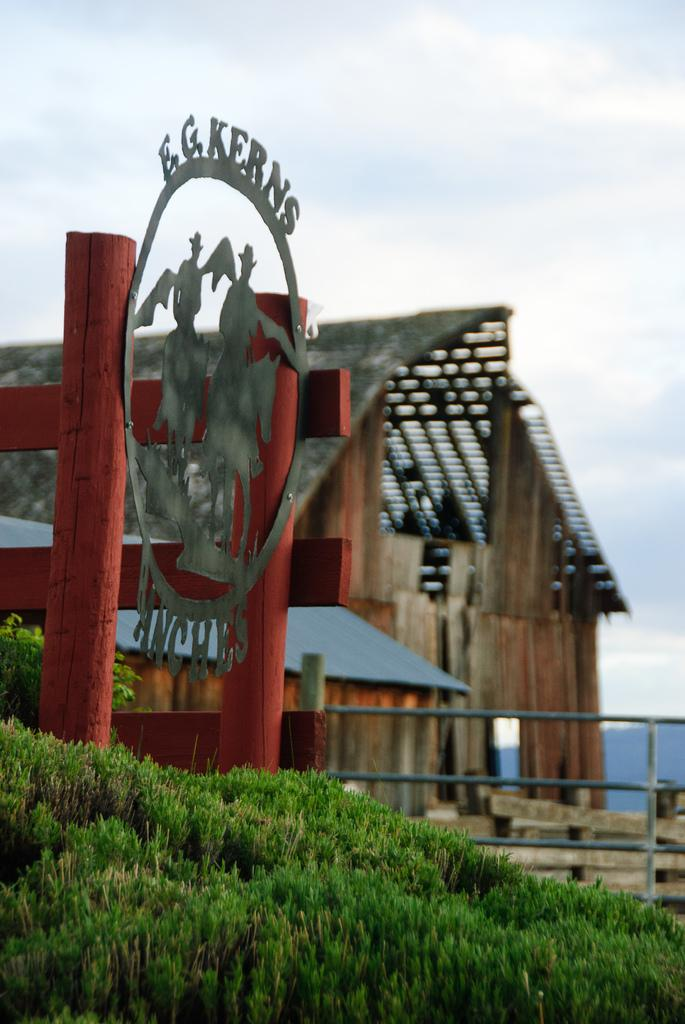<image>
Summarize the visual content of the image. The metal sign shown in this image is for E.G. kerns. 